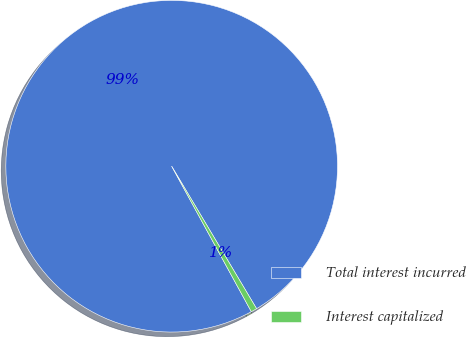Convert chart to OTSL. <chart><loc_0><loc_0><loc_500><loc_500><pie_chart><fcel>Total interest incurred<fcel>Interest capitalized<nl><fcel>99.42%<fcel>0.58%<nl></chart> 